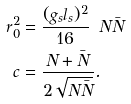Convert formula to latex. <formula><loc_0><loc_0><loc_500><loc_500>r _ { 0 } ^ { 2 } & = \frac { ( g _ { s } l _ { s } ) ^ { 2 } } { 1 6 } \, \ N \bar { N } \\ c & = \frac { N + \bar { N } } { 2 \sqrt { N \bar { N } } } .</formula> 